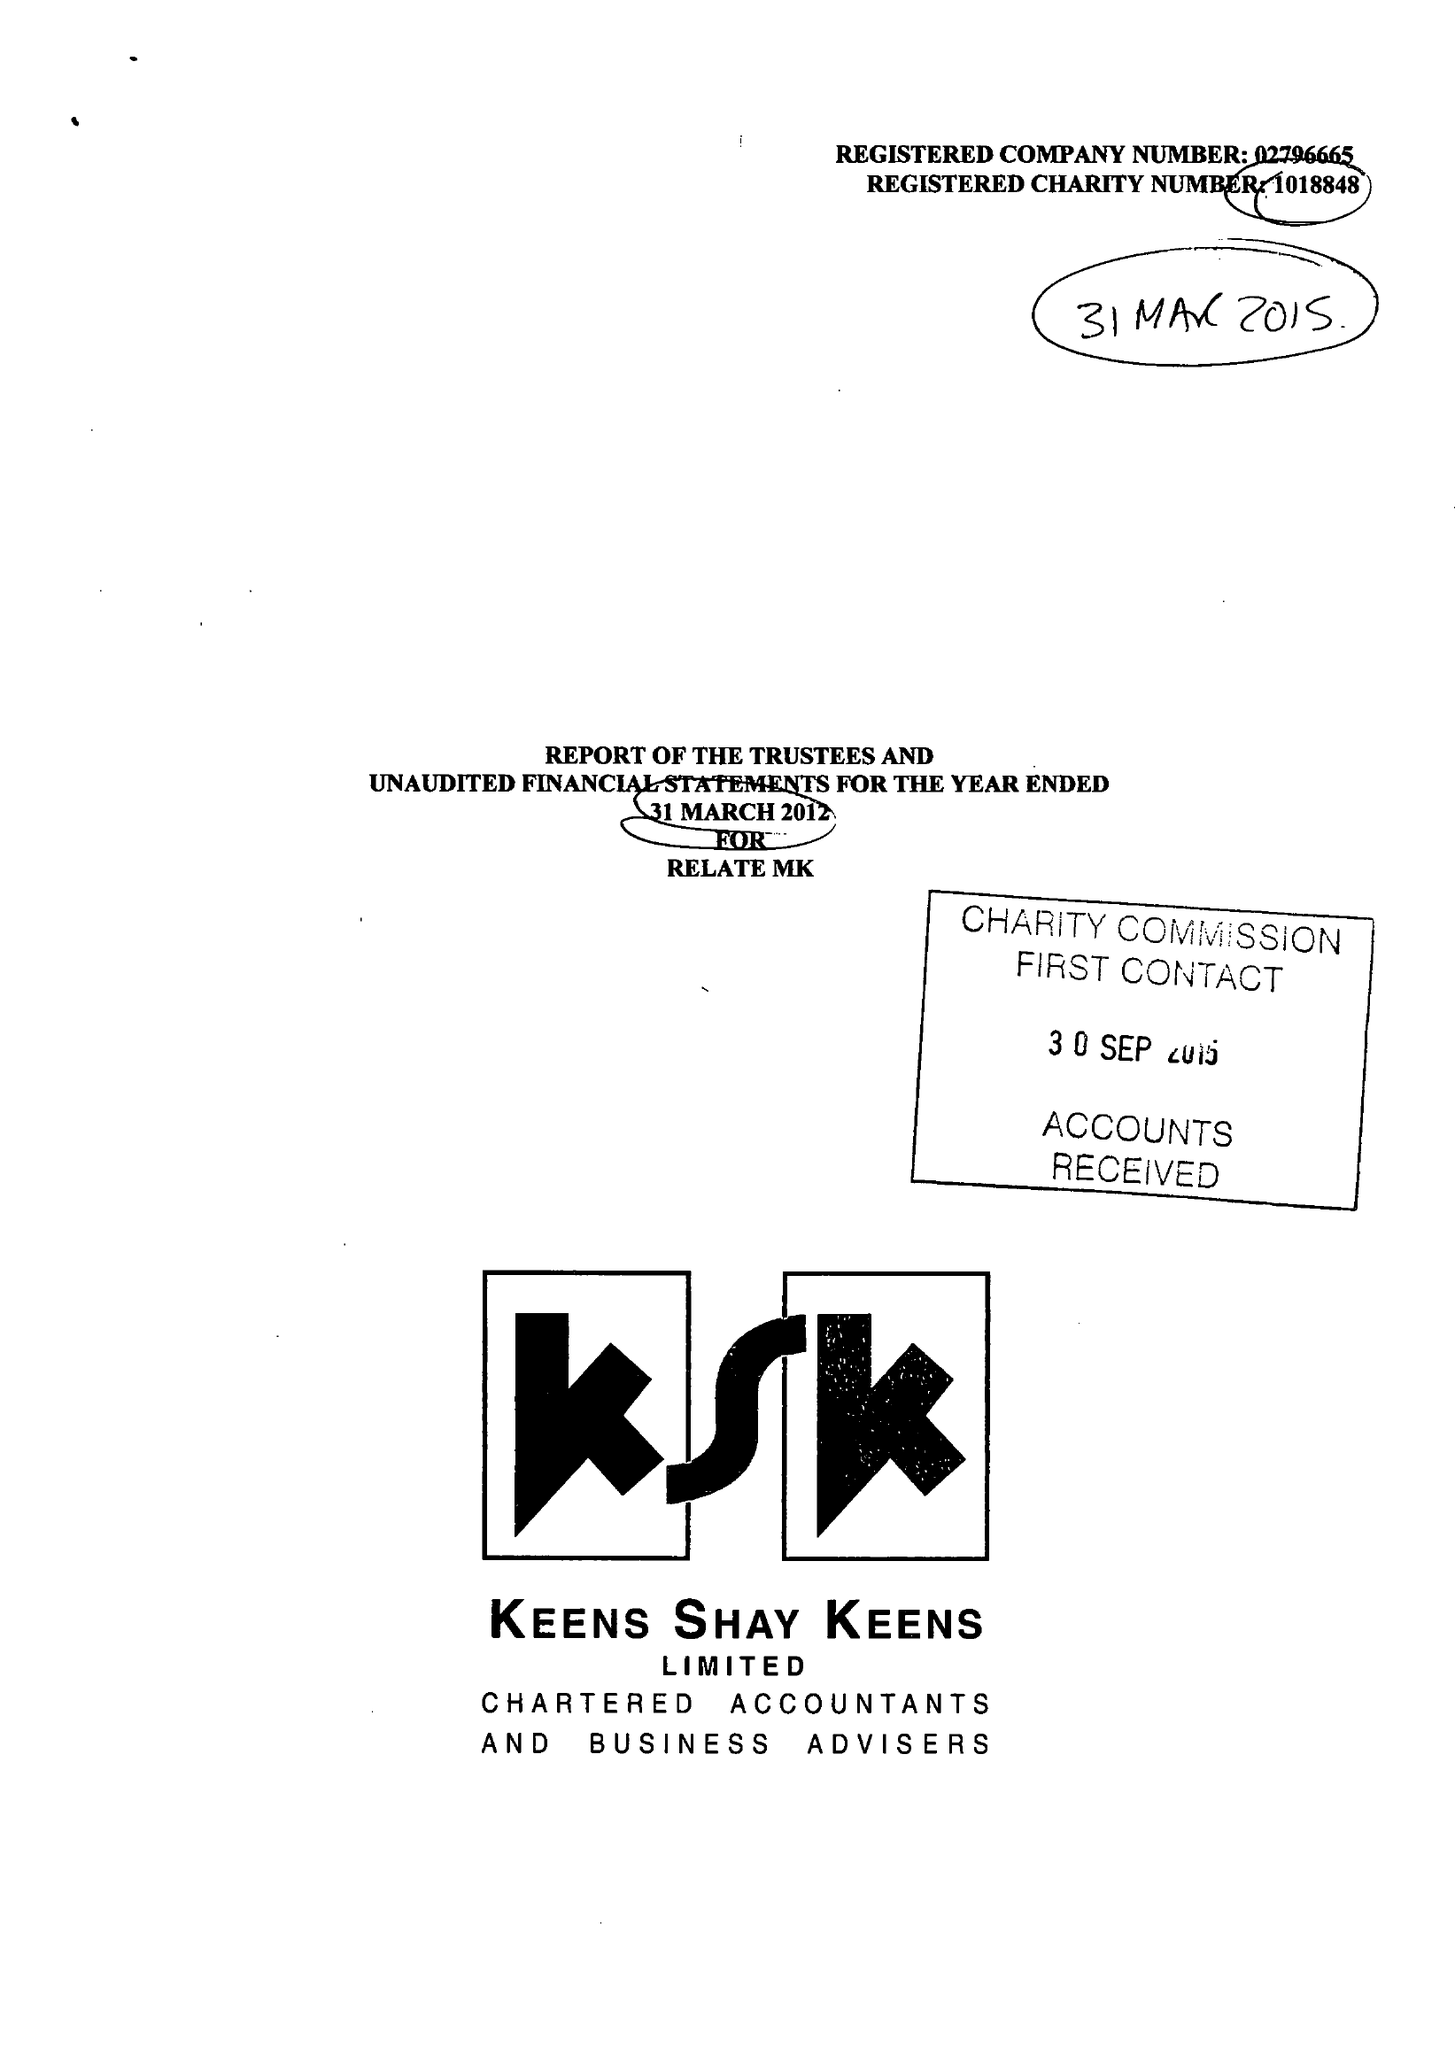What is the value for the charity_number?
Answer the question using a single word or phrase. 1018848 